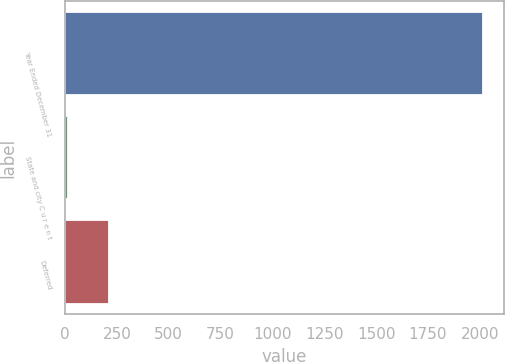<chart> <loc_0><loc_0><loc_500><loc_500><bar_chart><fcel>Year Ended December 31<fcel>State and city C u r e n t<fcel>Deferred<nl><fcel>2016<fcel>13<fcel>213.3<nl></chart> 